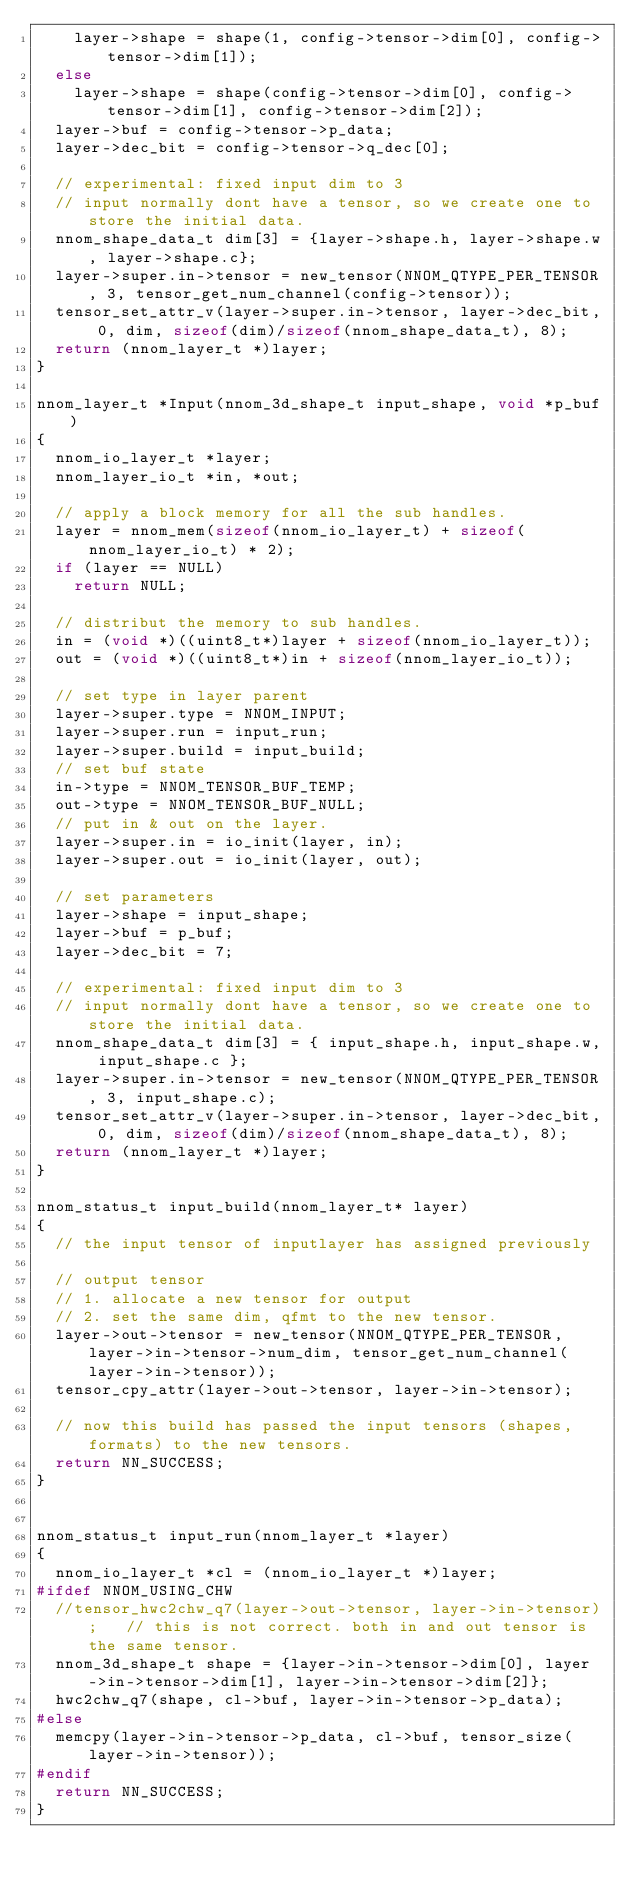<code> <loc_0><loc_0><loc_500><loc_500><_C_>		layer->shape = shape(1, config->tensor->dim[0], config->tensor->dim[1]);
	else
		layer->shape = shape(config->tensor->dim[0], config->tensor->dim[1], config->tensor->dim[2]);
	layer->buf = config->tensor->p_data;
	layer->dec_bit = config->tensor->q_dec[0];

	// experimental: fixed input dim to 3
	// input normally dont have a tensor, so we create one to store the initial data. 
	nnom_shape_data_t dim[3] = {layer->shape.h, layer->shape.w, layer->shape.c};
	layer->super.in->tensor = new_tensor(NNOM_QTYPE_PER_TENSOR, 3, tensor_get_num_channel(config->tensor));
	tensor_set_attr_v(layer->super.in->tensor, layer->dec_bit, 0, dim, sizeof(dim)/sizeof(nnom_shape_data_t), 8);
	return (nnom_layer_t *)layer;
}

nnom_layer_t *Input(nnom_3d_shape_t input_shape, void *p_buf)
{
	nnom_io_layer_t *layer;
	nnom_layer_io_t *in, *out;

	// apply a block memory for all the sub handles.
	layer = nnom_mem(sizeof(nnom_io_layer_t) + sizeof(nnom_layer_io_t) * 2);
	if (layer == NULL)
		return NULL;

	// distribut the memory to sub handles.
	in = (void *)((uint8_t*)layer + sizeof(nnom_io_layer_t));
	out = (void *)((uint8_t*)in + sizeof(nnom_layer_io_t));

	// set type in layer parent
	layer->super.type = NNOM_INPUT;
	layer->super.run = input_run;
	layer->super.build = input_build;
	// set buf state
	in->type = NNOM_TENSOR_BUF_TEMP;
	out->type = NNOM_TENSOR_BUF_NULL;
	// put in & out on the layer.
	layer->super.in = io_init(layer, in);
	layer->super.out = io_init(layer, out);

	// set parameters
	layer->shape = input_shape;
	layer->buf = p_buf;
	layer->dec_bit = 7;

	// experimental: fixed input dim to 3
	// input normally dont have a tensor, so we create one to store the initial data. 
	nnom_shape_data_t dim[3] = { input_shape.h, input_shape.w, input_shape.c };
	layer->super.in->tensor = new_tensor(NNOM_QTYPE_PER_TENSOR, 3, input_shape.c);
	tensor_set_attr_v(layer->super.in->tensor, layer->dec_bit, 0, dim, sizeof(dim)/sizeof(nnom_shape_data_t), 8);
	return (nnom_layer_t *)layer;
}

nnom_status_t input_build(nnom_layer_t* layer)
{
	// the input tensor of inputlayer has assigned previously 

	// output tensor
	// 1. allocate a new tensor for output
	// 2. set the same dim, qfmt to the new tensor.
	layer->out->tensor = new_tensor(NNOM_QTYPE_PER_TENSOR, layer->in->tensor->num_dim, tensor_get_num_channel(layer->in->tensor));
	tensor_cpy_attr(layer->out->tensor, layer->in->tensor);

	// now this build has passed the input tensors (shapes, formats) to the new tensors. 
	return NN_SUCCESS;
}


nnom_status_t input_run(nnom_layer_t *layer)
{
	nnom_io_layer_t *cl = (nnom_io_layer_t *)layer;
#ifdef NNOM_USING_CHW
	//tensor_hwc2chw_q7(layer->out->tensor, layer->in->tensor); 	// this is not correct. both in and out tensor is the same tensor. 
	nnom_3d_shape_t shape = {layer->in->tensor->dim[0], layer->in->tensor->dim[1], layer->in->tensor->dim[2]};
	hwc2chw_q7(shape, cl->buf, layer->in->tensor->p_data);
#else
	memcpy(layer->in->tensor->p_data, cl->buf, tensor_size(layer->in->tensor));
#endif
	return NN_SUCCESS;
}
</code> 